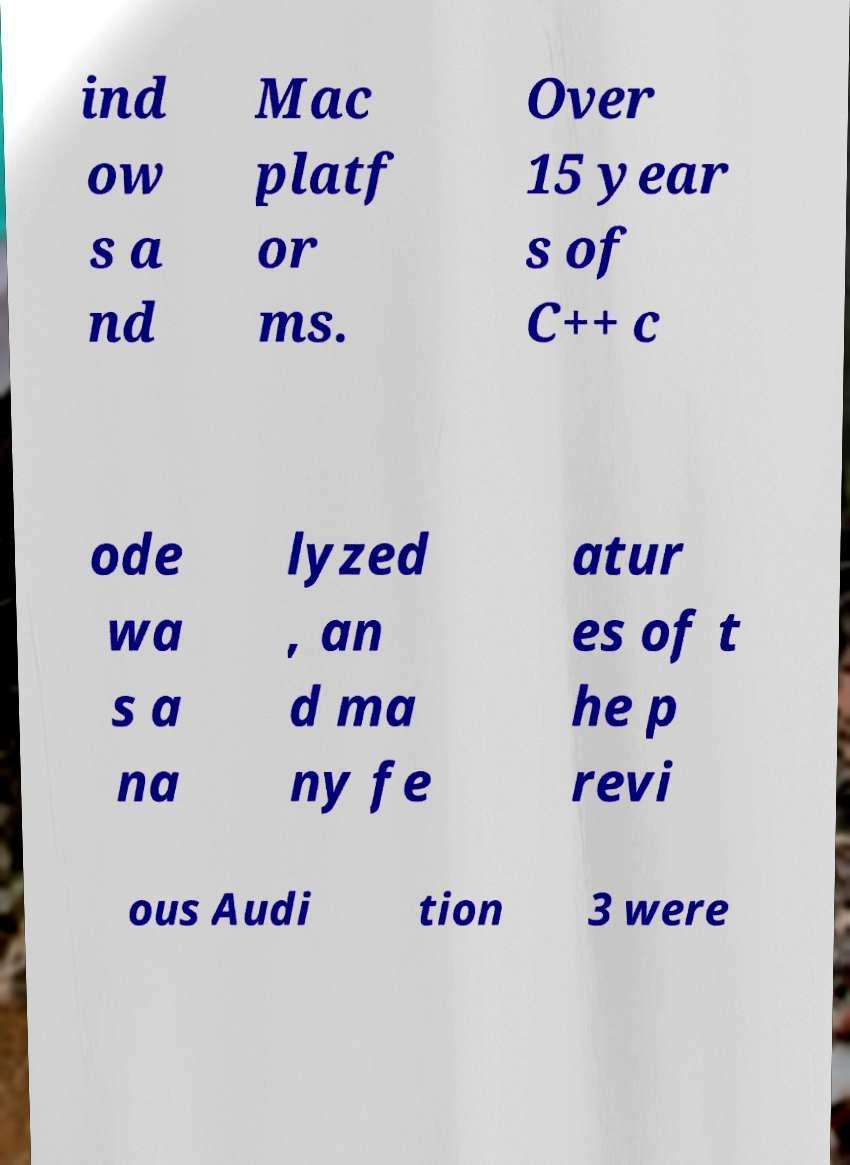For documentation purposes, I need the text within this image transcribed. Could you provide that? ind ow s a nd Mac platf or ms. Over 15 year s of C++ c ode wa s a na lyzed , an d ma ny fe atur es of t he p revi ous Audi tion 3 were 